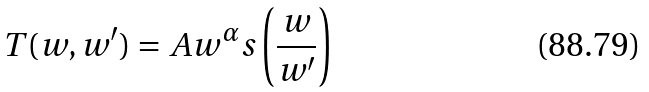<formula> <loc_0><loc_0><loc_500><loc_500>T ( w , w ^ { \prime } ) = A w ^ { \alpha } s \left ( \frac { w } { w ^ { \prime } } \right )</formula> 